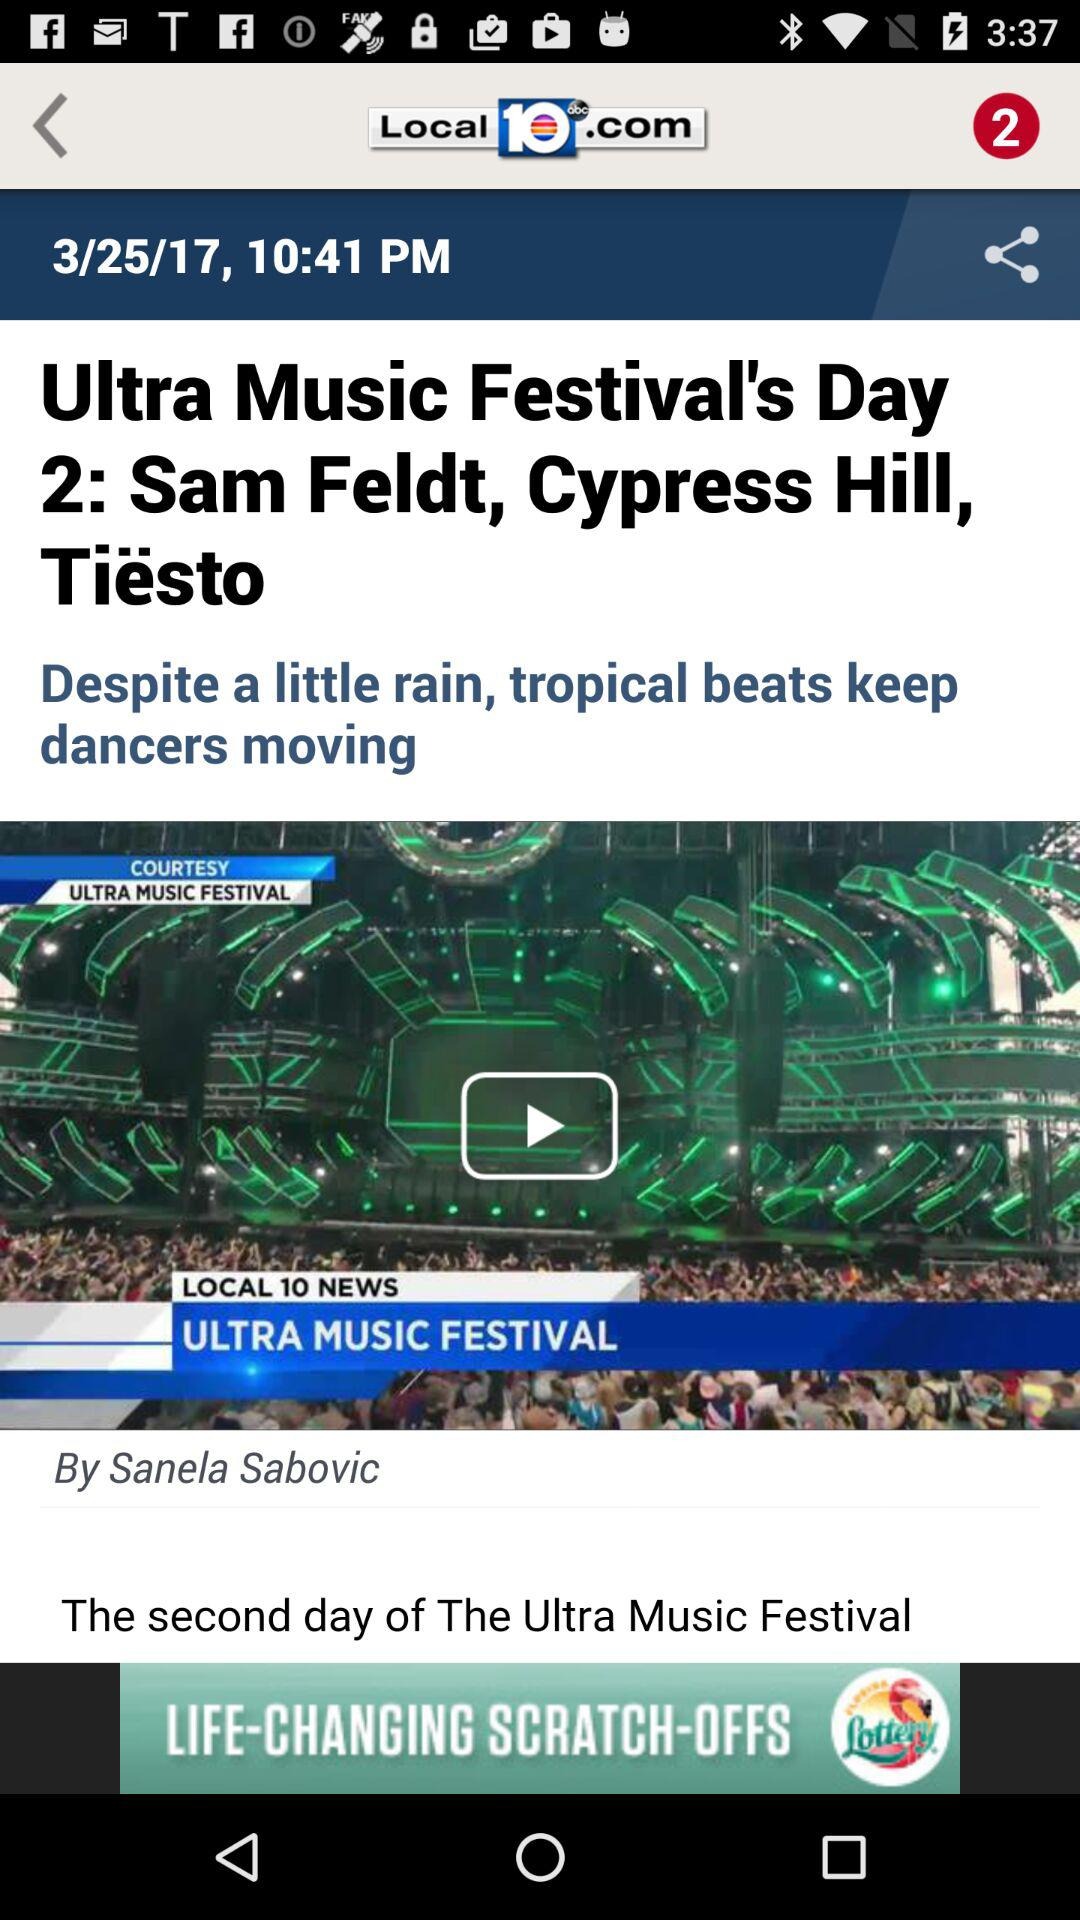What is the television station name? The television station name is "LOCAL 10". 